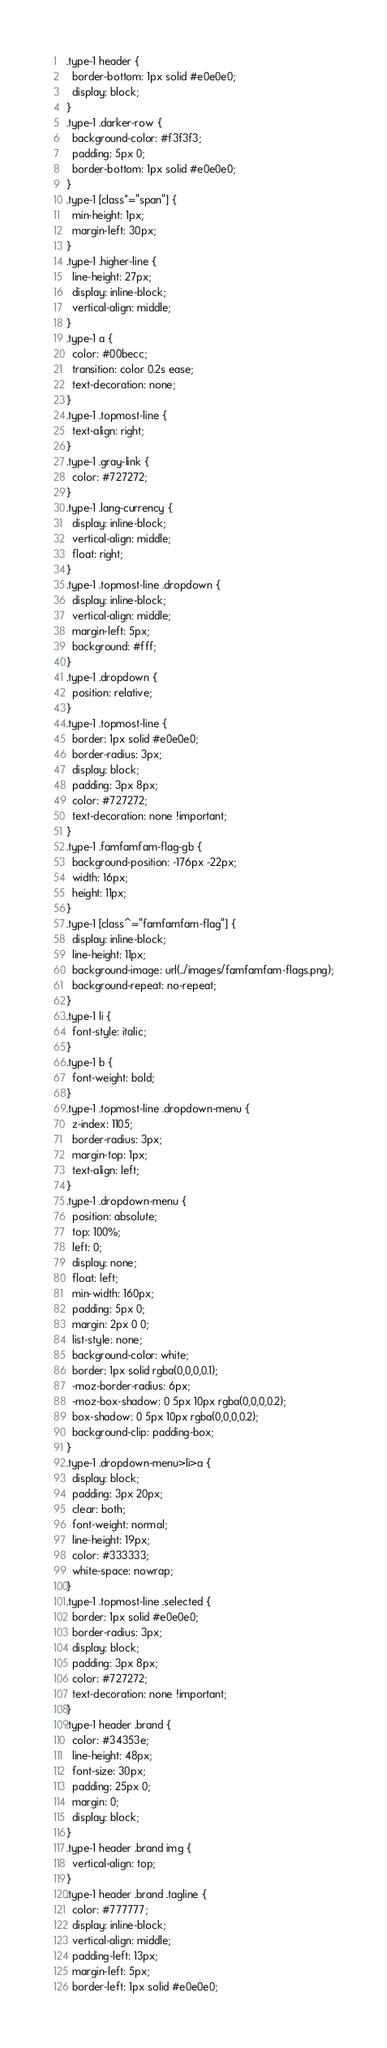<code> <loc_0><loc_0><loc_500><loc_500><_CSS_>.type-1 header {
  border-bottom: 1px solid #e0e0e0;
  display: block;
}
.type-1 .darker-row {
  background-color: #f3f3f3;
  padding: 5px 0;
  border-bottom: 1px solid #e0e0e0;
}
.type-1 [class*="span"] {
  min-height: 1px;
  margin-left: 30px;
}
.type-1 .higher-line {
  line-height: 27px;
  display: inline-block;
  vertical-align: middle;
}
.type-1 a {
  color: #00becc;
  transition: color 0.2s ease;
  text-decoration: none;
}
.type-1 .topmost-line {
  text-align: right;
}
.type-1 .gray-link {
  color: #727272;
}
.type-1 .lang-currency {
  display: inline-block;
  vertical-align: middle;
  float: right;
}
.type-1 .topmost-line .dropdown {
  display: inline-block;
  vertical-align: middle;
  margin-left: 5px;
  background: #fff;
}
.type-1 .dropdown {
  position: relative;
}
.type-1 .topmost-line {
  border: 1px solid #e0e0e0;
  border-radius: 3px;
  display: block;
  padding: 3px 8px;
  color: #727272;
  text-decoration: none !important;
}
.type-1 .famfamfam-flag-gb {
  background-position: -176px -22px;
  width: 16px;
  height: 11px;
}
.type-1 [class^="famfamfam-flag"] {
  display: inline-block;
  line-height: 11px;
  background-image: url(../images/famfamfam-flags.png);
  background-repeat: no-repeat;
}
.type-1 li {
  font-style: italic;
}
.type-1 b {
  font-weight: bold;
}
.type-1 .topmost-line .dropdown-menu {
  z-index: 1105;
  border-radius: 3px;
  margin-top: 1px;
  text-align: left;
}
.type-1 .dropdown-menu {
  position: absolute;
  top: 100%;
  left: 0;
  display: none;
  float: left;
  min-width: 160px;
  padding: 5px 0;
  margin: 2px 0 0;
  list-style: none;
  background-color: white;
  border: 1px solid rgba(0,0,0,0.1);
  -moz-border-radius: 6px;
  -moz-box-shadow: 0 5px 10px rgba(0,0,0,0.2);
  box-shadow: 0 5px 10px rgba(0,0,0,0.2);
  background-clip: padding-box;
}
.type-1 .dropdown-menu>li>a {
  display: block;
  padding: 3px 20px;
  clear: both;
  font-weight: normal;
  line-height: 19px;
  color: #333333;
  white-space: nowrap;
}
.type-1 .topmost-line .selected {
  border: 1px solid #e0e0e0;
  border-radius: 3px;
  display: block;
  padding: 3px 8px;
  color: #727272;
  text-decoration: none !important;
}
.type-1 header .brand {
  color: #34353e;
  line-height: 48px;
  font-size: 30px;
  padding: 25px 0;
  margin: 0;
  display: block;
}
.type-1 header .brand img {
  vertical-align: top;
}
.type-1 header .brand .tagline {
  color: #777777;
  display: inline-block;
  vertical-align: middle;
  padding-left: 13px;
  margin-left: 5px;
  border-left: 1px solid #e0e0e0;</code> 